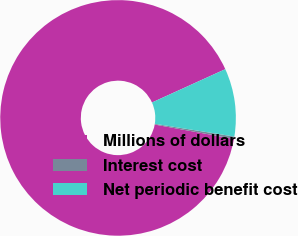<chart> <loc_0><loc_0><loc_500><loc_500><pie_chart><fcel>Millions of dollars<fcel>Interest cost<fcel>Net periodic benefit cost<nl><fcel>90.36%<fcel>0.32%<fcel>9.32%<nl></chart> 